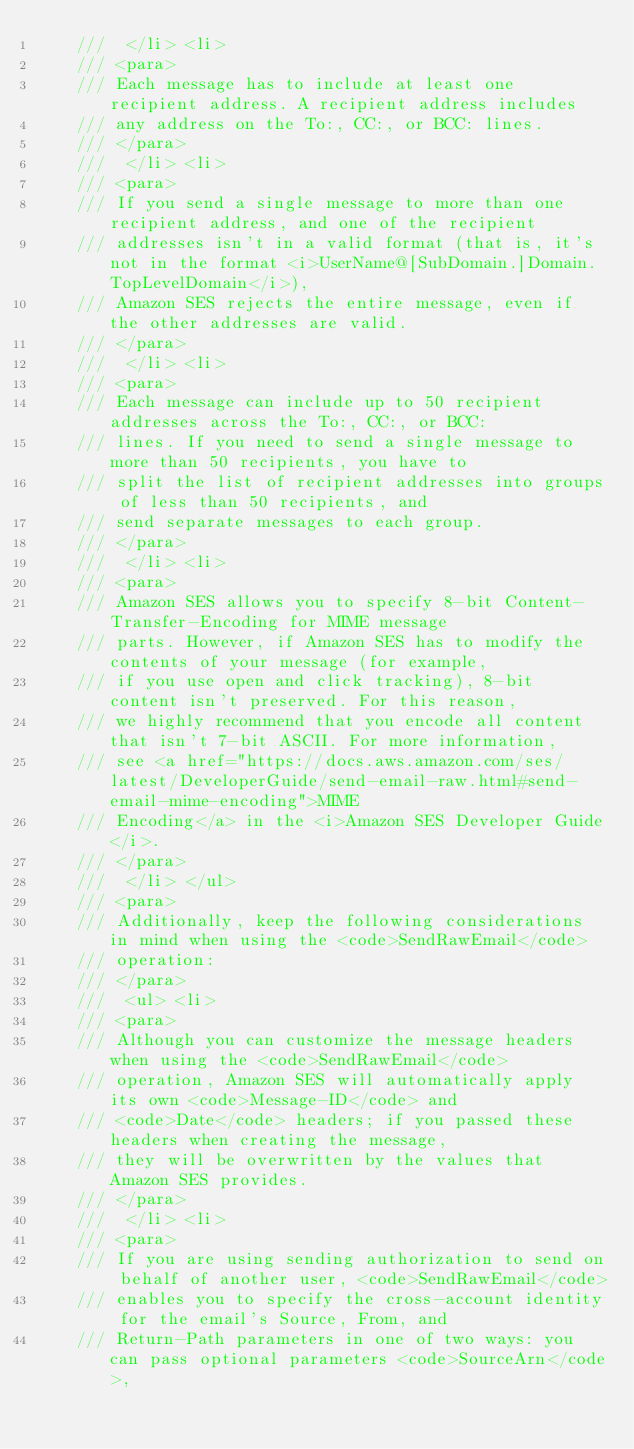Convert code to text. <code><loc_0><loc_0><loc_500><loc_500><_C#_>    ///  </li> <li> 
    /// <para>
    /// Each message has to include at least one recipient address. A recipient address includes
    /// any address on the To:, CC:, or BCC: lines.
    /// </para>
    ///  </li> <li> 
    /// <para>
    /// If you send a single message to more than one recipient address, and one of the recipient
    /// addresses isn't in a valid format (that is, it's not in the format <i>UserName@[SubDomain.]Domain.TopLevelDomain</i>),
    /// Amazon SES rejects the entire message, even if the other addresses are valid.
    /// </para>
    ///  </li> <li> 
    /// <para>
    /// Each message can include up to 50 recipient addresses across the To:, CC:, or BCC:
    /// lines. If you need to send a single message to more than 50 recipients, you have to
    /// split the list of recipient addresses into groups of less than 50 recipients, and
    /// send separate messages to each group.
    /// </para>
    ///  </li> <li> 
    /// <para>
    /// Amazon SES allows you to specify 8-bit Content-Transfer-Encoding for MIME message
    /// parts. However, if Amazon SES has to modify the contents of your message (for example,
    /// if you use open and click tracking), 8-bit content isn't preserved. For this reason,
    /// we highly recommend that you encode all content that isn't 7-bit ASCII. For more information,
    /// see <a href="https://docs.aws.amazon.com/ses/latest/DeveloperGuide/send-email-raw.html#send-email-mime-encoding">MIME
    /// Encoding</a> in the <i>Amazon SES Developer Guide</i>.
    /// </para>
    ///  </li> </ul> 
    /// <para>
    /// Additionally, keep the following considerations in mind when using the <code>SendRawEmail</code>
    /// operation:
    /// </para>
    ///  <ul> <li> 
    /// <para>
    /// Although you can customize the message headers when using the <code>SendRawEmail</code>
    /// operation, Amazon SES will automatically apply its own <code>Message-ID</code> and
    /// <code>Date</code> headers; if you passed these headers when creating the message,
    /// they will be overwritten by the values that Amazon SES provides.
    /// </para>
    ///  </li> <li> 
    /// <para>
    /// If you are using sending authorization to send on behalf of another user, <code>SendRawEmail</code>
    /// enables you to specify the cross-account identity for the email's Source, From, and
    /// Return-Path parameters in one of two ways: you can pass optional parameters <code>SourceArn</code>,</code> 